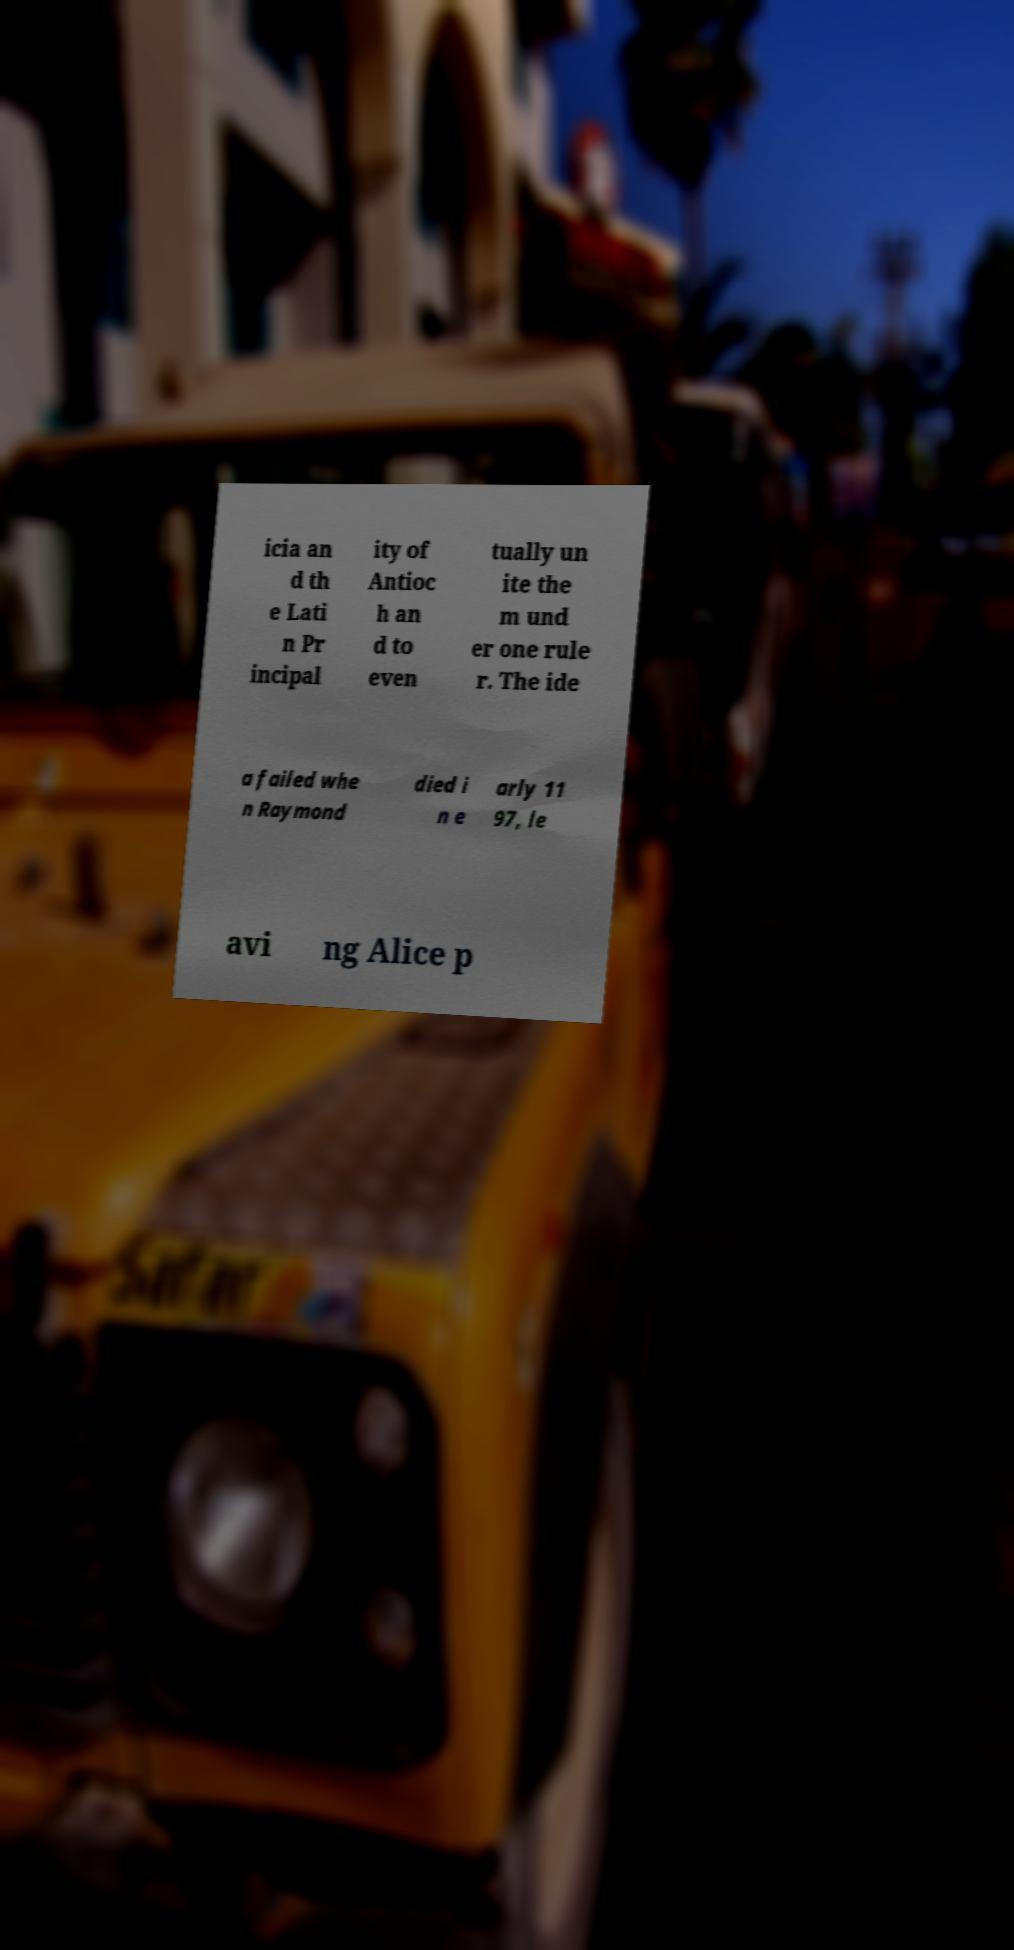Can you read and provide the text displayed in the image?This photo seems to have some interesting text. Can you extract and type it out for me? icia an d th e Lati n Pr incipal ity of Antioc h an d to even tually un ite the m und er one rule r. The ide a failed whe n Raymond died i n e arly 11 97, le avi ng Alice p 